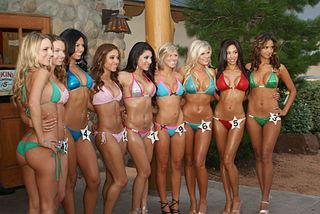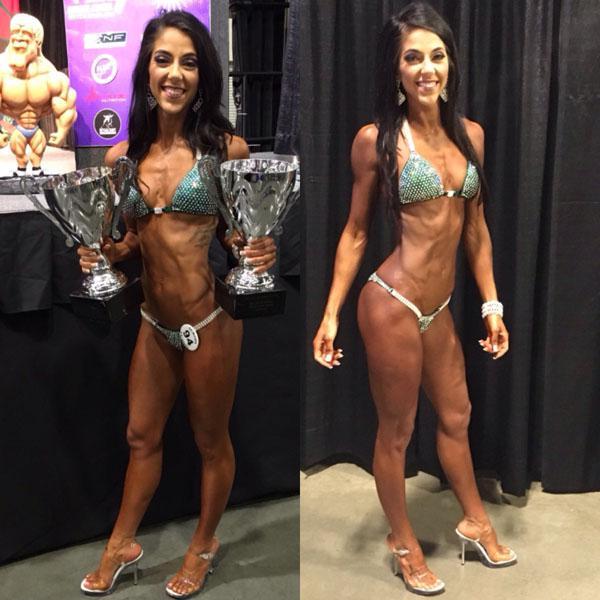The first image is the image on the left, the second image is the image on the right. Evaluate the accuracy of this statement regarding the images: "In at least one image there are at least two identical women in blue bikinis.". Is it true? Answer yes or no. Yes. The first image is the image on the left, the second image is the image on the right. Examine the images to the left and right. Is the description "A single blonde woman is wearing a bikini in one of the images." accurate? Answer yes or no. No. 